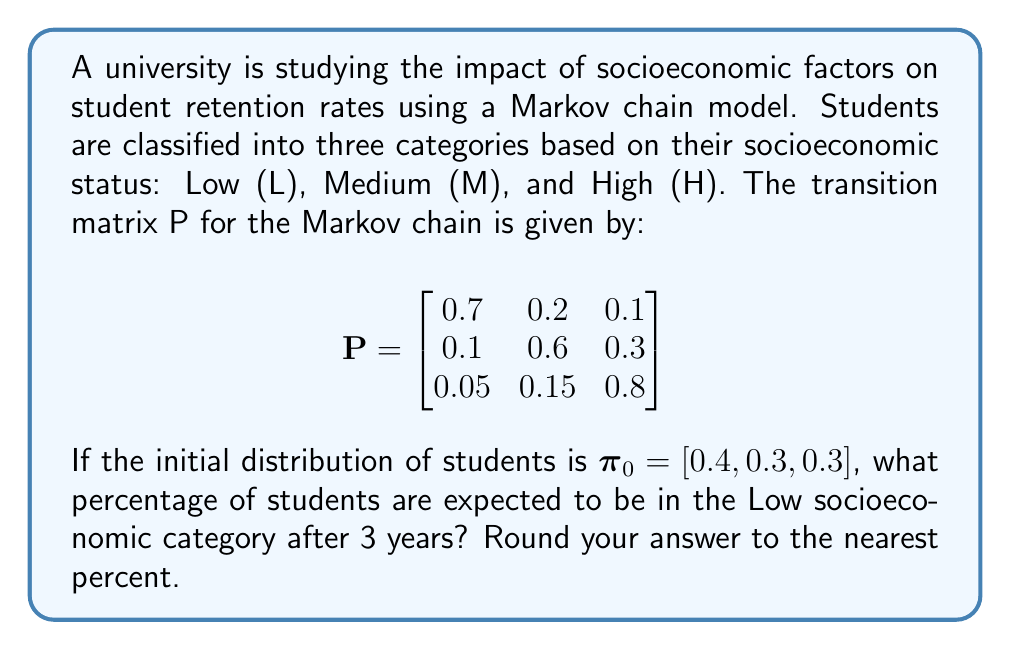Solve this math problem. To solve this problem, we need to calculate the distribution of students after 3 years using the given Markov chain model. Let's follow these steps:

1) The initial distribution is given as $\pi_0 = [0.4, 0.3, 0.3]$.

2) To find the distribution after 3 years, we need to multiply $\pi_0$ by $P^3$ (the transition matrix raised to the power of 3).

3) First, let's calculate $P^2$:

   $$P^2 = P \times P = \begin{bmatrix}
   0.51 & 0.27 & 0.22 \\
   0.145 & 0.435 & 0.42 \\
   0.0725 & 0.1875 & 0.74
   \end{bmatrix}$$

4) Now, let's calculate $P^3$:

   $$P^3 = P^2 \times P = \begin{bmatrix}
   0.4095 & 0.2985 & 0.292 \\
   0.1795 & 0.3375 & 0.483 \\
   0.09125 & 0.20625 & 0.7025
   \end{bmatrix}$$

5) Now, we multiply $\pi_0$ by $P^3$:

   $$\pi_3 = \pi_0 \times P^3 = [0.4, 0.3, 0.3] \times \begin{bmatrix}
   0.4095 & 0.2985 & 0.292 \\
   0.1795 & 0.3375 & 0.483 \\
   0.09125 & 0.20625 & 0.7025
   \end{bmatrix}$$

6) Performing this multiplication:

   $$\pi_3 = [0.2501, 0.2835, 0.4664]$$

7) The probability of a student being in the Low socioeconomic category after 3 years is the first element of $\pi_3$, which is 0.2501.

8) Converting to a percentage and rounding to the nearest percent:

   0.2501 * 100 ≈ 25%

Therefore, approximately 25% of students are expected to be in the Low socioeconomic category after 3 years.
Answer: 25% 